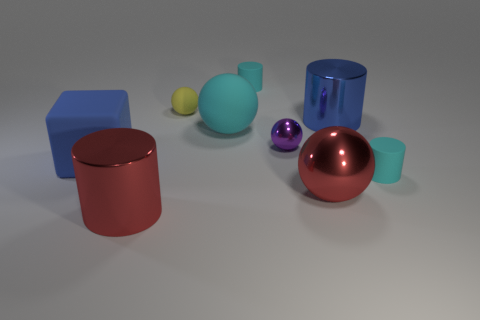Subtract all blue cylinders. How many cylinders are left? 3 Add 1 tiny yellow matte balls. How many objects exist? 10 Subtract all blue cylinders. How many cylinders are left? 3 Subtract all spheres. How many objects are left? 5 Subtract all yellow cylinders. How many cyan spheres are left? 1 Add 3 small cylinders. How many small cylinders are left? 5 Add 5 yellow spheres. How many yellow spheres exist? 6 Subtract 0 gray cylinders. How many objects are left? 9 Subtract 3 spheres. How many spheres are left? 1 Subtract all brown cylinders. Subtract all green blocks. How many cylinders are left? 4 